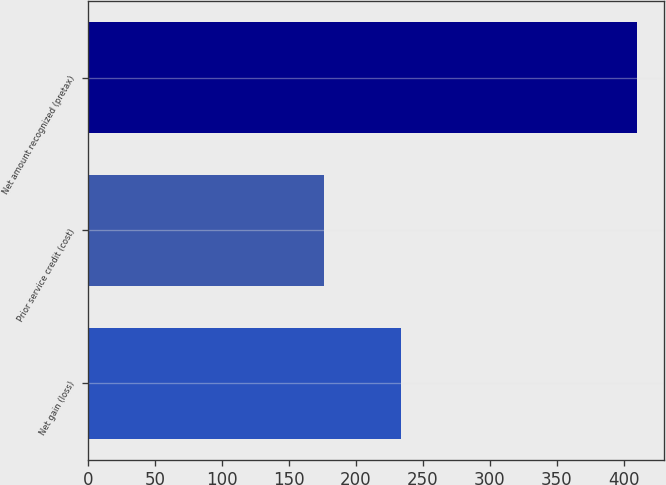Convert chart. <chart><loc_0><loc_0><loc_500><loc_500><bar_chart><fcel>Net gain (loss)<fcel>Prior service credit (cost)<fcel>Net amount recognized (pretax)<nl><fcel>234<fcel>176<fcel>410<nl></chart> 